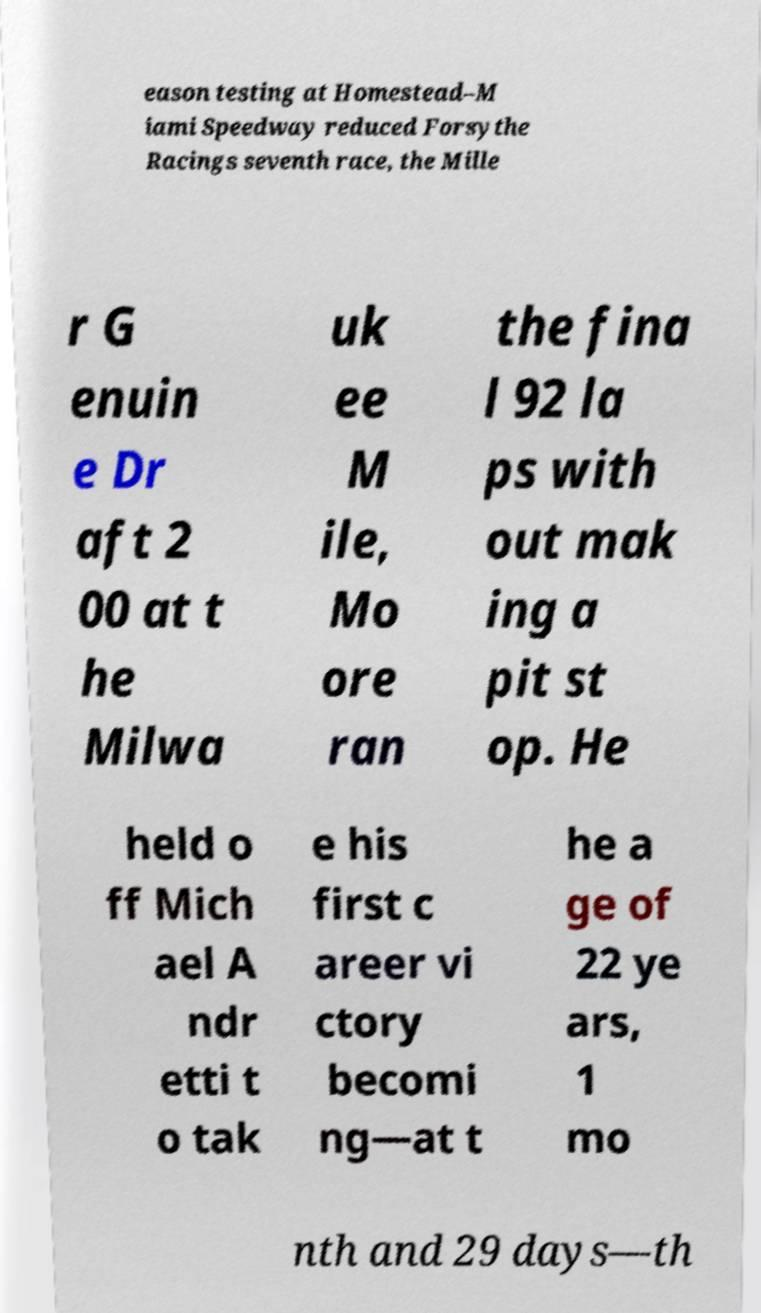There's text embedded in this image that I need extracted. Can you transcribe it verbatim? eason testing at Homestead–M iami Speedway reduced Forsythe Racings seventh race, the Mille r G enuin e Dr aft 2 00 at t he Milwa uk ee M ile, Mo ore ran the fina l 92 la ps with out mak ing a pit st op. He held o ff Mich ael A ndr etti t o tak e his first c areer vi ctory becomi ng—at t he a ge of 22 ye ars, 1 mo nth and 29 days—th 